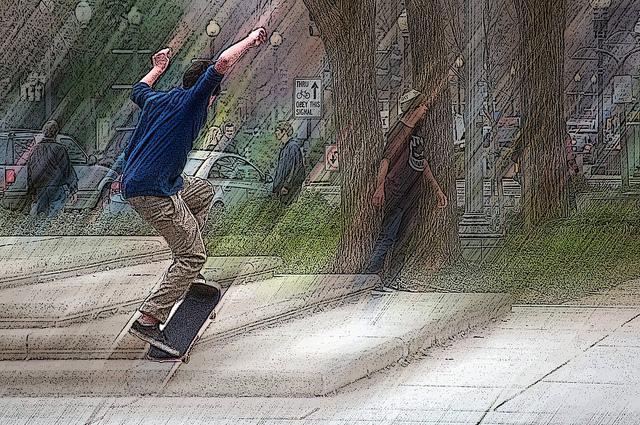How many steps are there on the stairs?
Give a very brief answer. 4. How many cars are visible?
Give a very brief answer. 2. How many people are in the photo?
Give a very brief answer. 4. 